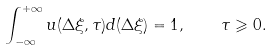Convert formula to latex. <formula><loc_0><loc_0><loc_500><loc_500>\int _ { - \infty } ^ { + \infty } u ( \Delta \xi , \tau ) d ( \Delta \xi ) = 1 , \quad \tau \geqslant 0 .</formula> 